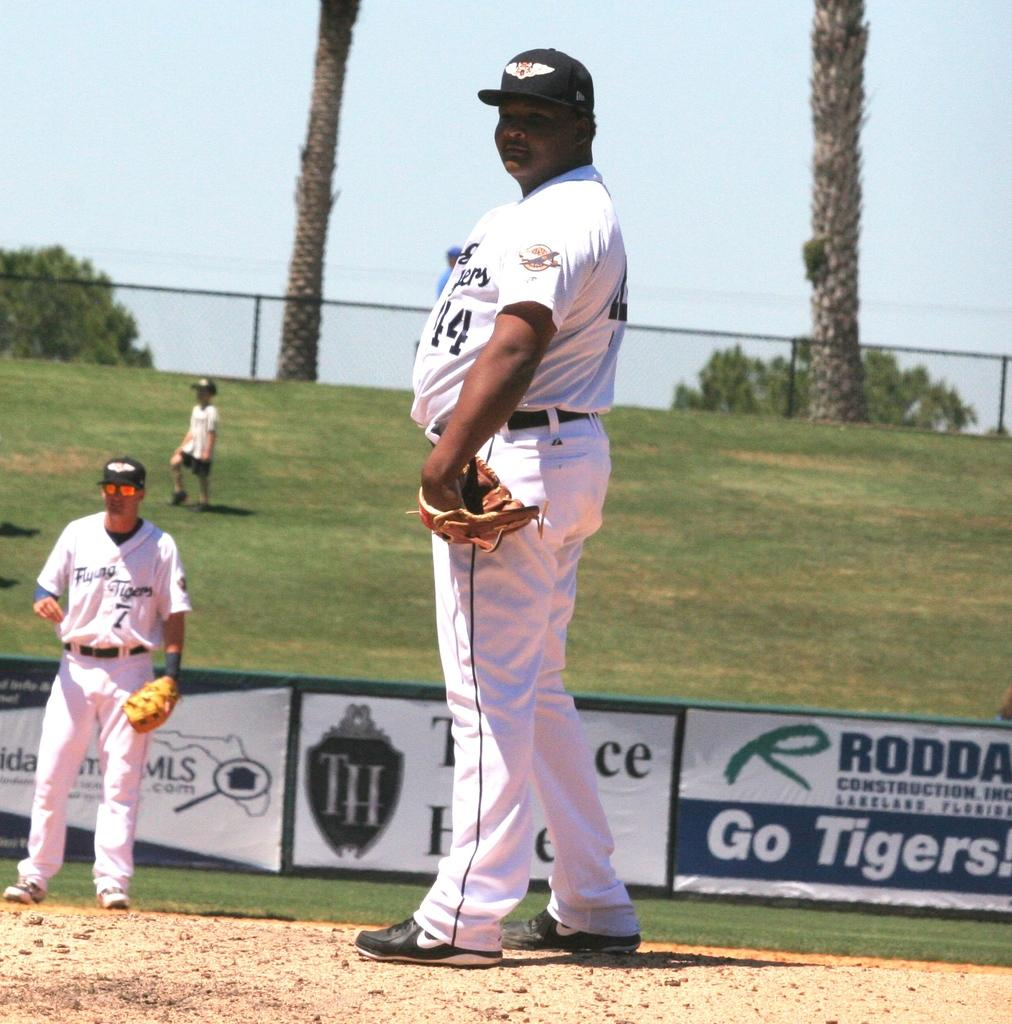<image>
Render a clear and concise summary of the photo. Baseball player wearing number 44 getting ready to pitch the ball. 